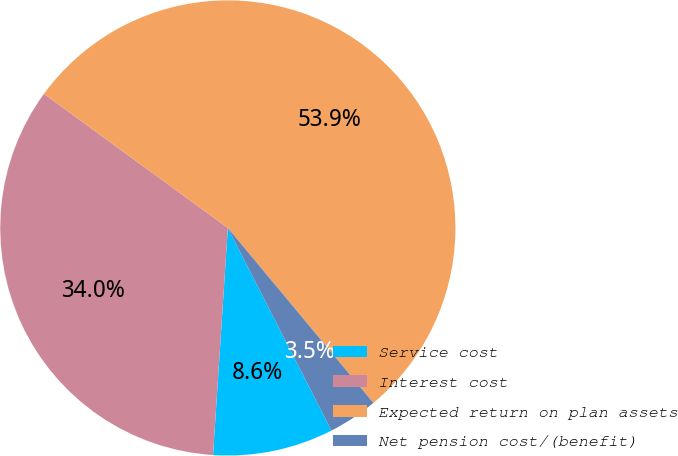<chart> <loc_0><loc_0><loc_500><loc_500><pie_chart><fcel>Service cost<fcel>Interest cost<fcel>Expected return on plan assets<fcel>Net pension cost/(benefit)<nl><fcel>8.56%<fcel>34.0%<fcel>53.93%<fcel>3.52%<nl></chart> 